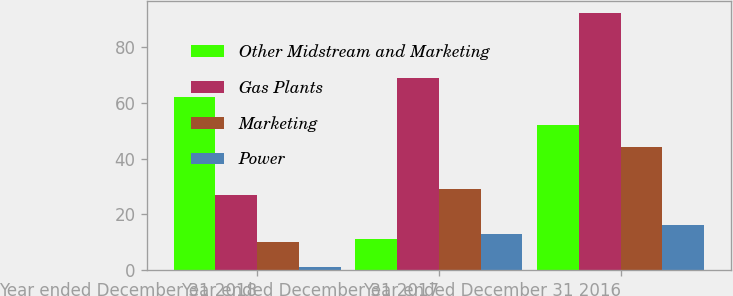Convert chart to OTSL. <chart><loc_0><loc_0><loc_500><loc_500><stacked_bar_chart><ecel><fcel>Year ended December 31 2018<fcel>Year ended December 31 2017<fcel>Year ended December 31 2016<nl><fcel>Other Midstream and Marketing<fcel>62<fcel>11<fcel>52<nl><fcel>Gas Plants<fcel>27<fcel>69<fcel>92<nl><fcel>Marketing<fcel>10<fcel>29<fcel>44<nl><fcel>Power<fcel>1<fcel>13<fcel>16<nl></chart> 